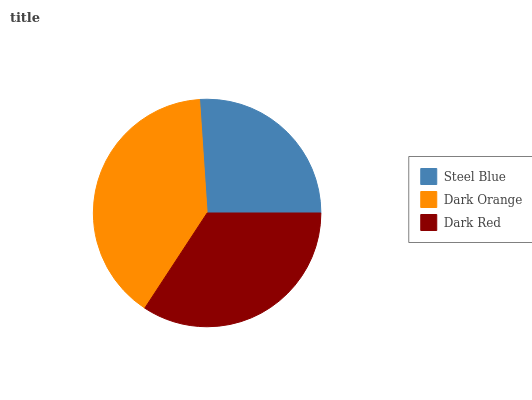Is Steel Blue the minimum?
Answer yes or no. Yes. Is Dark Orange the maximum?
Answer yes or no. Yes. Is Dark Red the minimum?
Answer yes or no. No. Is Dark Red the maximum?
Answer yes or no. No. Is Dark Orange greater than Dark Red?
Answer yes or no. Yes. Is Dark Red less than Dark Orange?
Answer yes or no. Yes. Is Dark Red greater than Dark Orange?
Answer yes or no. No. Is Dark Orange less than Dark Red?
Answer yes or no. No. Is Dark Red the high median?
Answer yes or no. Yes. Is Dark Red the low median?
Answer yes or no. Yes. Is Dark Orange the high median?
Answer yes or no. No. Is Steel Blue the low median?
Answer yes or no. No. 